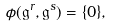<formula> <loc_0><loc_0><loc_500><loc_500>\phi ( \mathfrak { g } ^ { r } , \mathfrak { g } ^ { s } ) = \{ 0 \} ,</formula> 